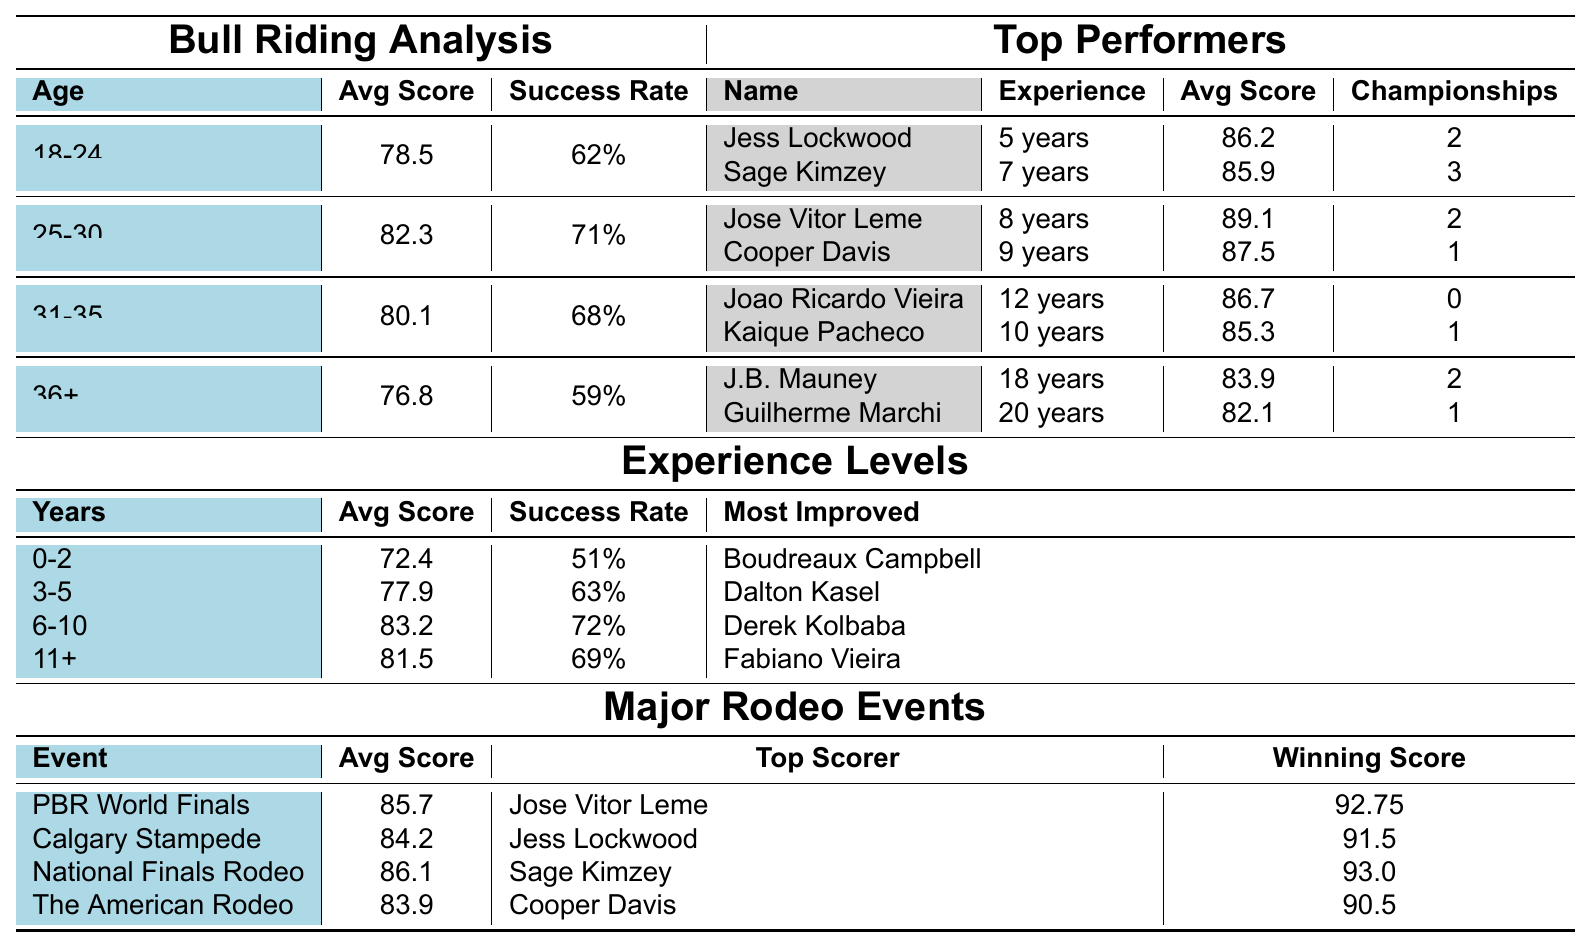What is the average score for riders aged 25-30? The table lists the average score for the age group 25-30 as 82.3.
Answer: 82.3 Who has the highest average score among the top performers in the age group 18-24? In the age group 18-24, Jess Lockwood has an average score of 86.2, which is higher than Sage Kimzey's 85.9.
Answer: Jess Lockwood What percentage of success rate do riders aged 36 and above have? The success rate for riders aged 36 and above is listed as 59%.
Answer: 59% Which experience level has the highest success rate? The experience level of 6-10 years has the highest success rate of 72%, compared to other levels.
Answer: 6-10 years Is Joao Ricardo Vieira a champion in bull riding? According to the table, Joao Ricardo Vieira has 0 championships, so he is not a champion.
Answer: No What is the average score difference between riders with 0-2 years of experience and those with 11+ years? The average score for 0-2 years is 72.4, and for 11+ years, it is 81.5. The difference is 81.5 - 72.4 = 9.1.
Answer: 9.1 Who is the most improved bull rider among those with 3-5 years of experience? The most improved rider in the 3-5 years experience level is Dalton Kasel.
Answer: Dalton Kasel If you combine the average scores of both the age group 31-35 and 36+, what is the total? The average score for the age group 31-35 is 80.1, and for 36+, it is 76.8. The total is 80.1 + 76.8 = 156.9.
Answer: 156.9 Which major rodeo event has the highest winning score? The National Finals Rodeo has the highest winning score at 93.0.
Answer: National Finals Rodeo Do riders aged 25-30 have a higher average score than those aged 31-35? Yes, riders aged 25-30 have an average score of 82.3, which is higher than the 80.1 of riders aged 31-35.
Answer: Yes 